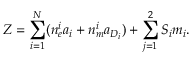Convert formula to latex. <formula><loc_0><loc_0><loc_500><loc_500>Z = \sum _ { i = 1 } ^ { N } ( n _ { e } ^ { i } a _ { i } + n _ { m } ^ { i } a _ { D _ { i } } ) + \sum _ { j = 1 } ^ { 2 } S _ { i } m _ { i } .</formula> 